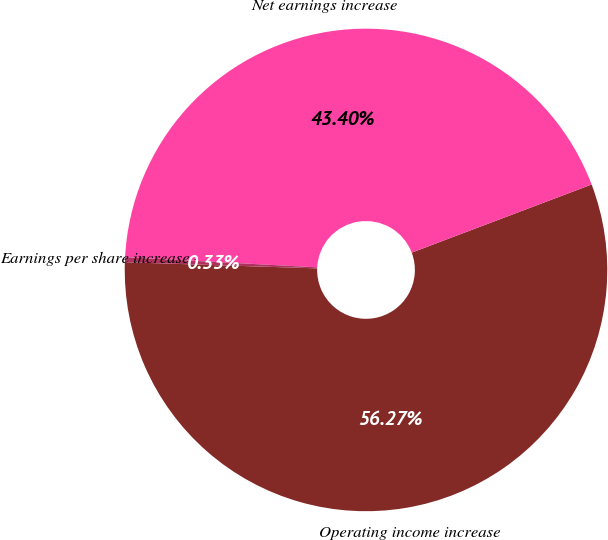<chart> <loc_0><loc_0><loc_500><loc_500><pie_chart><fcel>Operating income increase<fcel>Net earnings increase<fcel>Earnings per share increase -<nl><fcel>56.27%<fcel>43.4%<fcel>0.33%<nl></chart> 